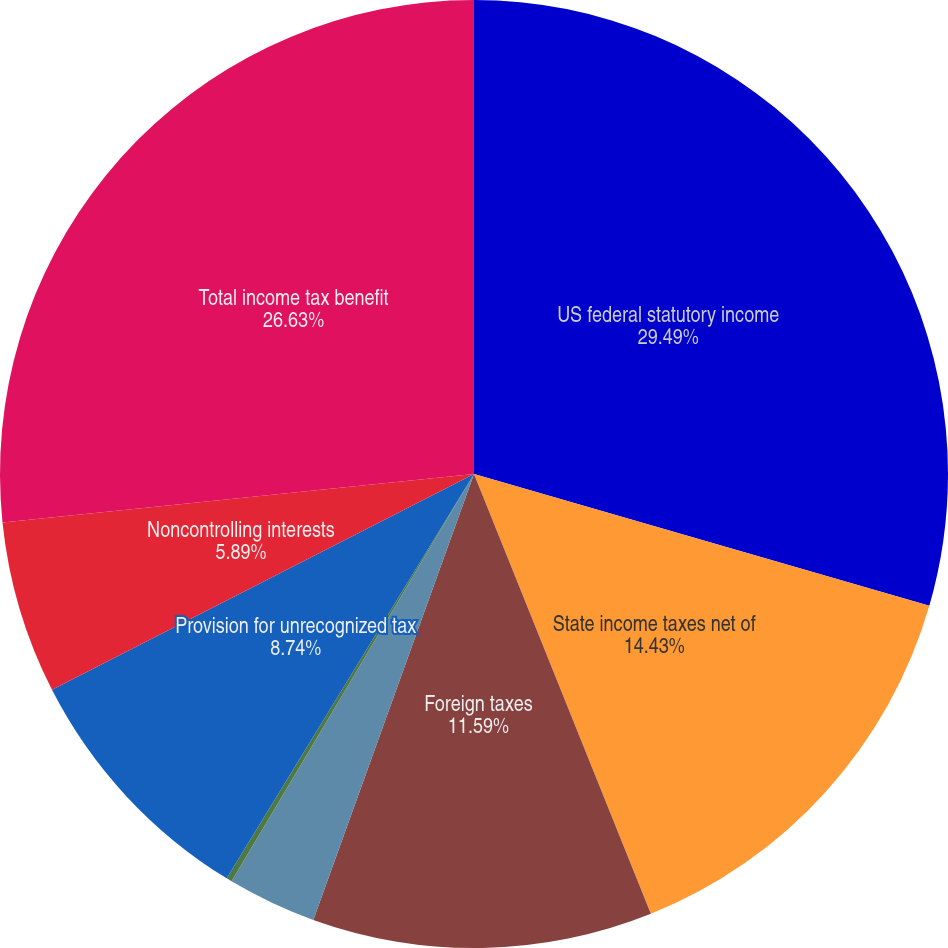Convert chart. <chart><loc_0><loc_0><loc_500><loc_500><pie_chart><fcel>US federal statutory income<fcel>State income taxes net of<fcel>Foreign taxes<fcel>Federal income tax credits<fcel>Medicare Part D subsidy<fcel>Provision for unrecognized tax<fcel>Noncontrolling interests<fcel>Total income tax benefit<nl><fcel>29.48%<fcel>14.43%<fcel>11.59%<fcel>3.04%<fcel>0.19%<fcel>8.74%<fcel>5.89%<fcel>26.63%<nl></chart> 